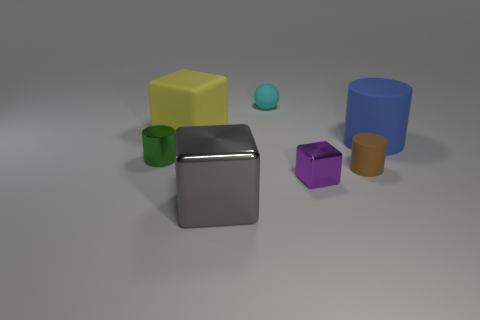Which objects are closest to the gray shiny cube? The purple cube and the blue cylinder are the closest objects to the gray shiny cube. 